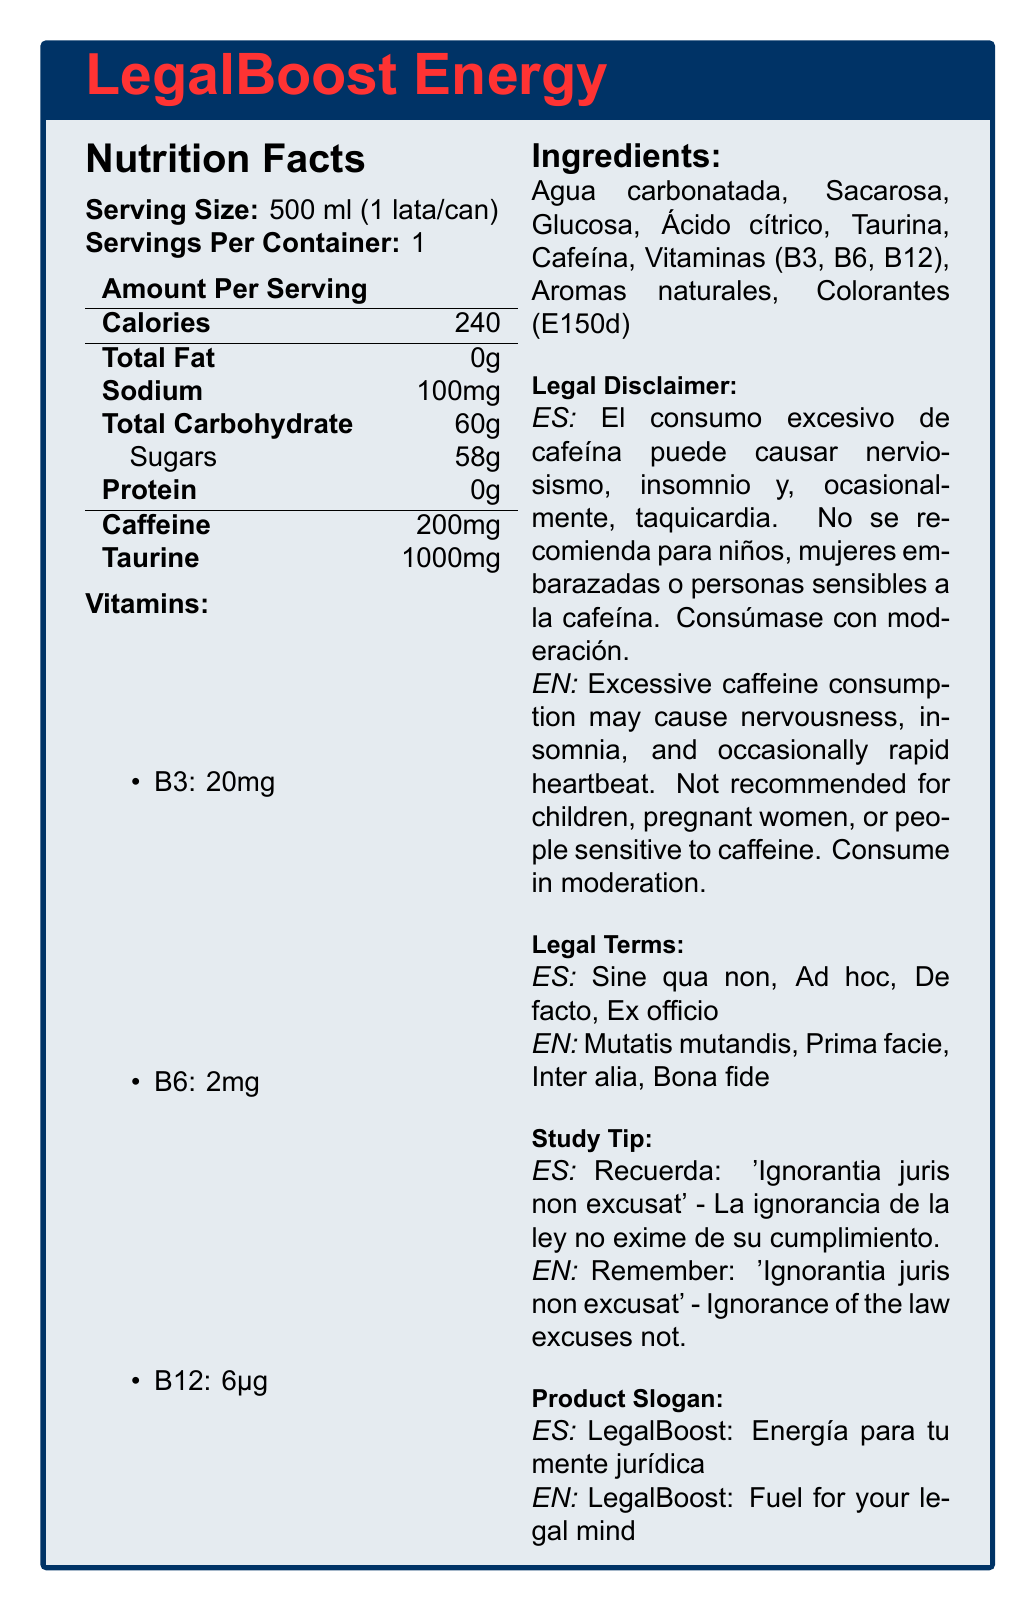what is the product name? The product name is clearly stated at the beginning of the document as "LegalBoost Energy".
Answer: LegalBoost Energy what is the serving size for the energy drink? The serving size is explicitly mentioned under the Nutrition Facts section as "Serving Size: 500 ml (1 lata/can)".
Answer: 500 ml (1 lata/can) how many calories are in one serving? The amount of calories per serving is listed under the Nutrition Facts section as "Calories: 240".
Answer: 240 list all the vitamins present in the product. Under the Nutrition Facts section, the vitamins listed are B3 (20mg), B6 (2mg), and B12 (6μg).
Answer: B3, B6, and B12 what are the main ingredients in LegalBoost Energy? The Ingredients section lists Agua carbonatada, Sacarosa, Glucosa, Ácido cítrico, Taurina, Cafeína, Vitaminas (B3, B6, B12), Aromas naturales, Colorantes (E150d).
Answer: Agua carbonatada, Sacarosa, Glucosa, Ácido cítrico, Taurina, Cafeína, Vitaminas (B3, B6, B12), Aromas naturales, Colorantes (E150d) how much caffeine is in one serving of LegalBoost Energy? In the Nutrition Facts section, the amount of caffeine per serving is listed as 200mg.
Answer: 200mg which of the following legal terms is mentioned in the document? I. Sine qua non II. Habeas Corpus III. Prima Facie The Legal Terms section lists "Sine qua non" and "Prima facie" but does not mention "Habeas Corpus".
Answer: I and III which vitamin has the highest amount in LegalBoost Energy? A. B3 B. B6 C. B12 The amounts of the vitamins are listed in the Nutrition Facts section: B3 (20mg), B6 (2mg), B12 (6μg), making Vitamin B3 the one with the highest amount.
Answer: A is it recommended for pregnant women to consume LegalBoost Energy? The Legal Disclaimer section states that the product is not recommended for pregnant women.
Answer: No summarize the document's main idea. The document includes detailed information about the energy drink "LegalBoost Energy", covering various sections like Nutrition Facts, Ingredients, Legal Disclaimer, Legal Terms, Study Tip, and Product Slogan.
Answer: LegalBoost Energy is an energy drink designed for legal students, providing details on nutritional content, ingredients, vitamins, legal disclaimers, legal terms, and a study tip. does the product slogan appear in both English and Spanish? The Product Slogan section provides the slogan in both English ("LegalBoost: Fuel for your legal mind") and Spanish ("LegalBoost: Energía para tu mente jurídica").
Answer: Yes how often can people sensitive to caffeine consume LegalBoost Energy? The Legal Disclaimer section clearly states that the product is not recommended for people sensitive to caffeine.
Answer: Not recommended what is the Spanish legal term for "Ignorance of the law excuses not"? The Study Tip section provides the Latin phrase "Ignorantia juris non excusat", indicating that ignorance of the law excuses not.
Answer: Ignorantia juris non excusat what are the possible side effects of consuming excessive caffeine according to the document? The Legal Disclaimer section mentions that excessive caffeine consumption may cause nervousness, insomnia, and occasionally rapid heartbeat.
Answer: Nervousness, insomnia, and occasionally rapid heartbeat how many legal terms are listed in English in the document? The Legal Terms section lists four English terms: Mutatis mutandis, Prima facie, Inter alia, Bona fide.
Answer: Four is the amount of fat in one serving of LegalBoost Energy significant? The Nutrition Facts section shows "Total Fat: 0g", indicating an insignificant amount of fat.
Answer: No could a person find information on the production process of LegalBoost Energy in the document? The document does not provide any details or information related to the production process of LegalBoost Energy.
Answer: Not enough information 